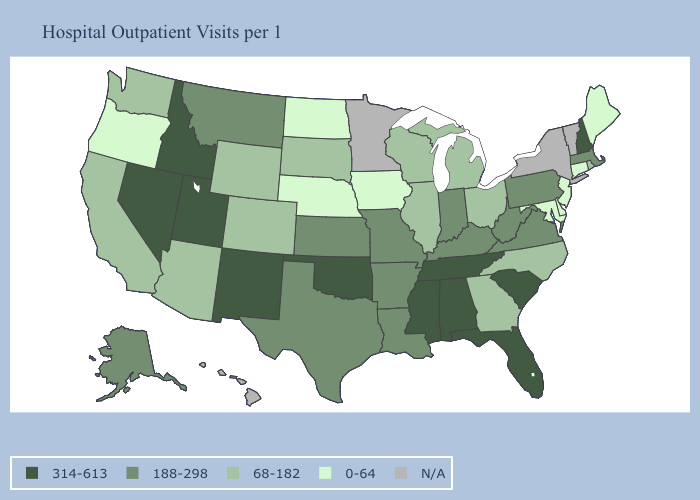Name the states that have a value in the range 188-298?
Quick response, please. Alaska, Arkansas, Indiana, Kansas, Kentucky, Louisiana, Massachusetts, Missouri, Montana, Pennsylvania, Texas, Virginia, West Virginia. Among the states that border Wyoming , does Utah have the lowest value?
Be succinct. No. What is the value of Montana?
Write a very short answer. 188-298. Does the first symbol in the legend represent the smallest category?
Concise answer only. No. Among the states that border Vermont , does New Hampshire have the lowest value?
Answer briefly. No. What is the value of Oklahoma?
Quick response, please. 314-613. What is the value of California?
Give a very brief answer. 68-182. Does Oregon have the highest value in the USA?
Keep it brief. No. Name the states that have a value in the range 0-64?
Answer briefly. Connecticut, Delaware, Iowa, Maine, Maryland, Nebraska, New Jersey, North Dakota, Oregon. What is the lowest value in states that border Connecticut?
Give a very brief answer. 68-182. Is the legend a continuous bar?
Keep it brief. No. What is the value of New Jersey?
Short answer required. 0-64. Name the states that have a value in the range N/A?
Be succinct. Hawaii, Minnesota, New York, Vermont. 